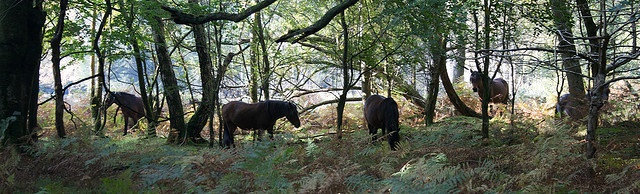Describe the objects in this image and their specific colors. I can see horse in black and gray tones, horse in black, gray, and darkgreen tones, horse in black and gray tones, horse in black, gray, darkgreen, and olive tones, and horse in black and gray tones in this image. 